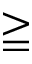<formula> <loc_0><loc_0><loc_500><loc_500>\geqq</formula> 